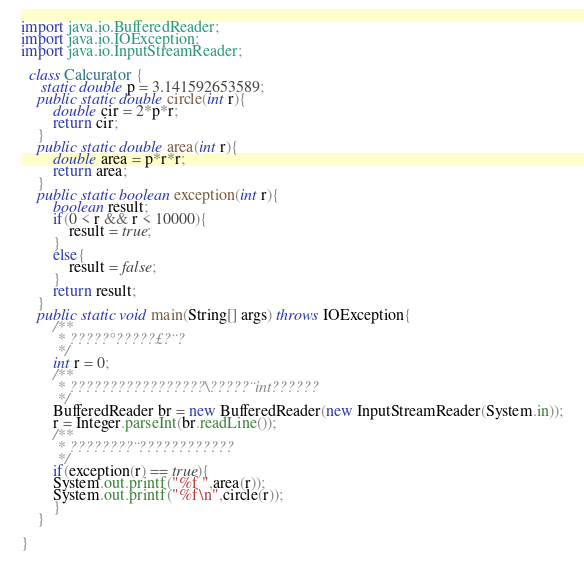Convert code to text. <code><loc_0><loc_0><loc_500><loc_500><_Java_>import java.io.BufferedReader;
import java.io.IOException;
import java.io.InputStreamReader;

  class Calcurator {
	 static double p = 3.141592653589;
	public static double circle(int r){
		double cir = 2*p*r;
		return cir;
	}
	public static double area(int r){
		double area = p*r*r;
		return area;
	}
	public static boolean exception(int r){
		boolean result;
		if(0 < r && r < 10000){
			result = true;
		}
		else{
			result = false;
		}
		return result;
	}
	public static void main(String[] args) throws IOException{
		/**
		 * ?????°?????£?¨?
		 */
		int r = 0;
		/**
		 * ?????????????????\?????¨int??????
		 */
		BufferedReader br = new BufferedReader(new InputStreamReader(System.in));
		r = Integer.parseInt(br.readLine());
		/**
		 * ????????¨????????????
		 */
		if(exception(r) == true){
		System.out.printf("%f ",area(r));
		System.out.printf("%f\n",circle(r));
		}
	}

}</code> 